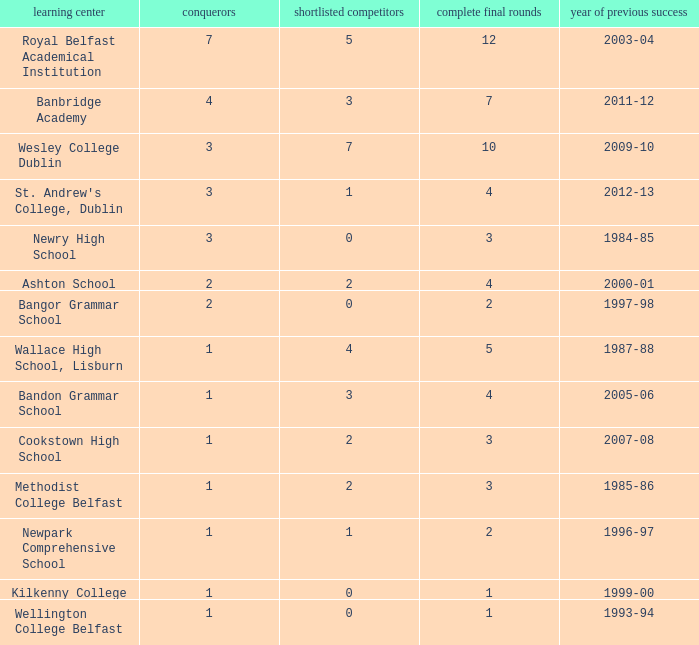What are the names that had a finalist score of 2? Ashton School, Cookstown High School, Methodist College Belfast. 